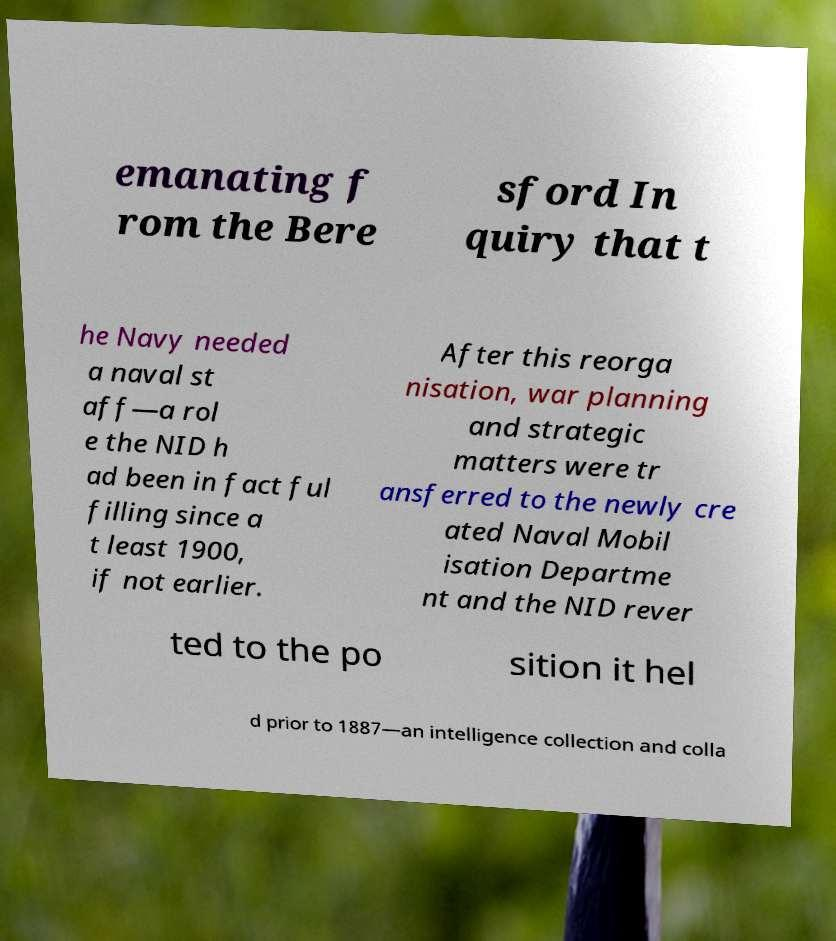What messages or text are displayed in this image? I need them in a readable, typed format. emanating f rom the Bere sford In quiry that t he Navy needed a naval st aff—a rol e the NID h ad been in fact ful filling since a t least 1900, if not earlier. After this reorga nisation, war planning and strategic matters were tr ansferred to the newly cre ated Naval Mobil isation Departme nt and the NID rever ted to the po sition it hel d prior to 1887—an intelligence collection and colla 